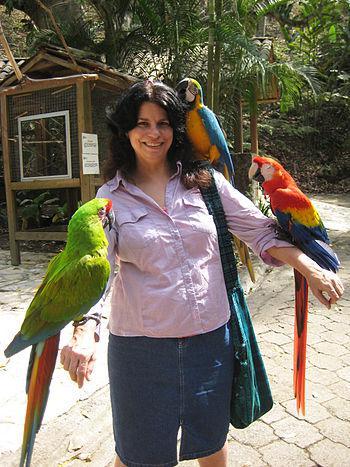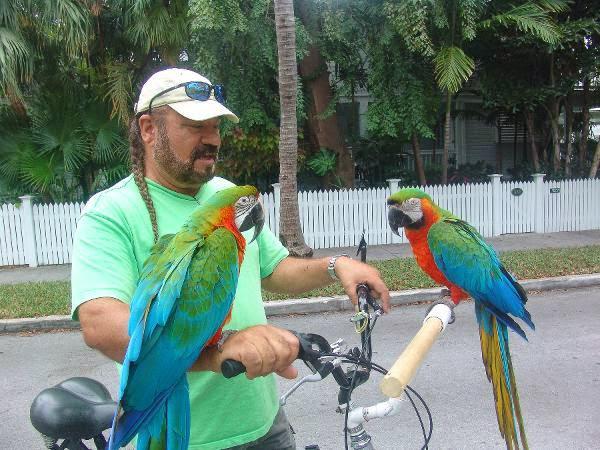The first image is the image on the left, the second image is the image on the right. For the images shown, is this caption "On both pictures, parrots can be seen perched on a human, one on each arm and one on a shoulder." true? Answer yes or no. No. 